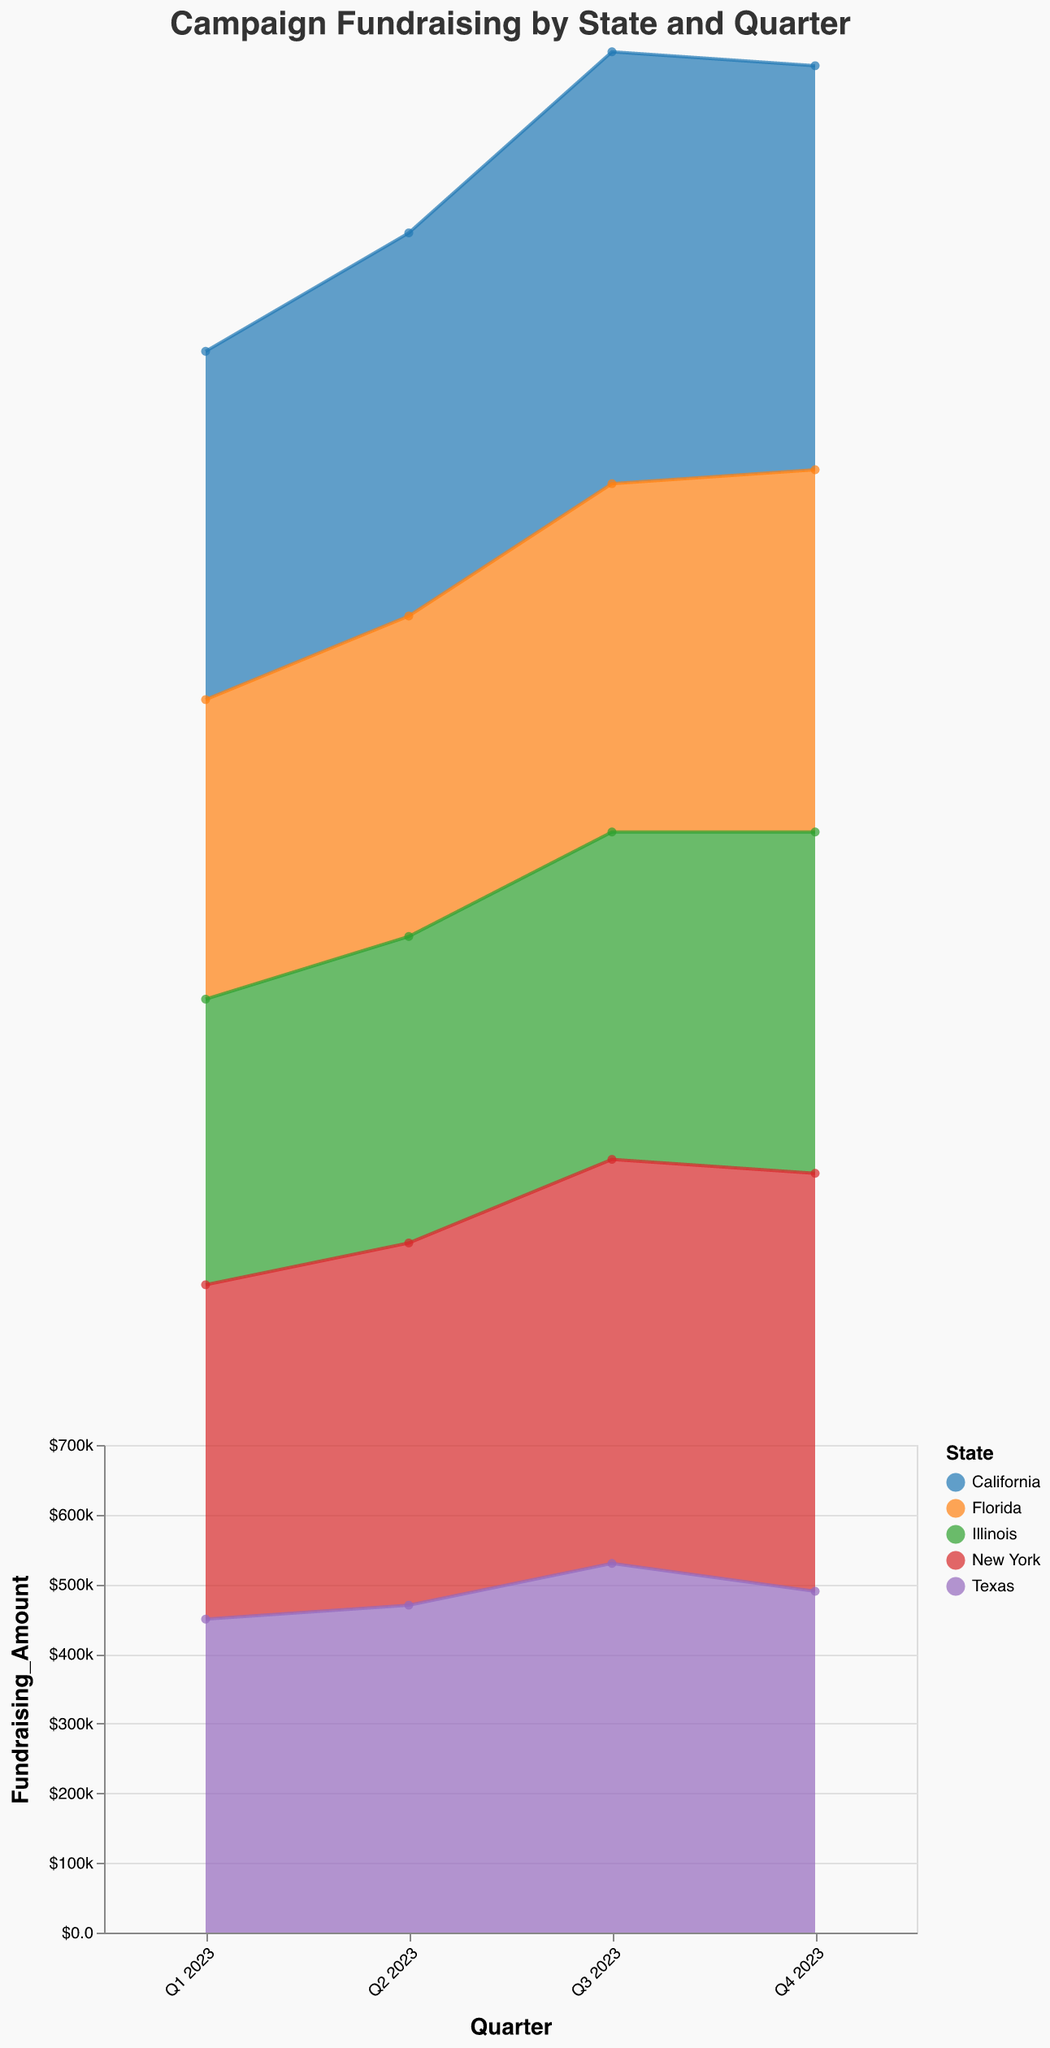How many states are represented in the area chart? The legend on the right side of the chart lists the states represented. Each color in the chart corresponds to a different state listed in the legend.
Answer: 5 Which state had the highest fundraising amount in Q3 2023? By observing the peaks of the areas in the chart for Q3 2023, the data points indicate that California reached the highest amount.
Answer: California What is the total fundraising amount for California across all quarters in 2023? Adding the fundraising amounts for California from Q1 to Q4 2023: 500000 + 550000 + 620000 + 580000.
Answer: $2,250,000 How does the fundraising amount of New York in Q4 2023 compare to Texas in the same quarter? By comparing the heights of the areas in Q4 2023 for New York and Texas, New York raised 600000, and Texas raised 490000.
Answer: New York > Texas What was the trend for Florida's fundraising amounts throughout 2023? Observing the area-specific color for Florida across the quarters: Q1 is 430000, Q2 is 460000, Q3 is 500000, Q4 is 520000. The trend shows a consistent increase.
Answer: Increasing Which quarter has the highest overall fundraising amount for all states combined? Summing the fundraising amounts for all states in each quarter: Q3: 620000 + 530000 + 580000 + 500000 + 470000 = 2700000, Q4: 580000 + 490000 + 600000 + 520000 + 490000 = 2680000. Q3 is the highest.
Answer: Q3 2023 What is the difference in fundraising amounts between California and Illinois in Q2 2023? Subtract Illinois' amount from California's amount in Q2 2023: 550000 (California) - 440000 (Illinois).
Answer: $110,000 What is the average fundraising amount for Texas across all quarters in 2023? Adding Texas's amounts for all quarters and dividing by 4 quarters: (450000 + 470000 + 530000 + 490000) / 4.
Answer: $485,000 Which states raised more than $500,000 in any quarter in 2023? Checking each state’s fundraising amount in all quarters to see if any amount exceeds 500,000. California (Q3, Q4), New York (Q3, Q4), Texas (Q3), and Florida (Q4) meet the criteria.
Answer: California, New York, Texas, Florida 